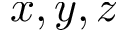<formula> <loc_0><loc_0><loc_500><loc_500>x , y , z</formula> 